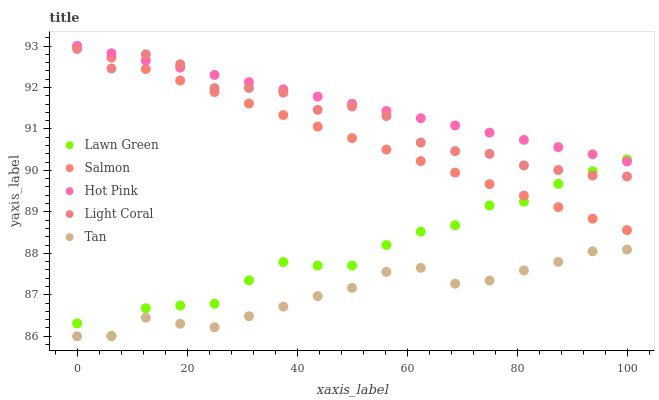Does Tan have the minimum area under the curve?
Answer yes or no. Yes. Does Hot Pink have the maximum area under the curve?
Answer yes or no. Yes. Does Lawn Green have the minimum area under the curve?
Answer yes or no. No. Does Lawn Green have the maximum area under the curve?
Answer yes or no. No. Is Hot Pink the smoothest?
Answer yes or no. Yes. Is Light Coral the roughest?
Answer yes or no. Yes. Is Lawn Green the smoothest?
Answer yes or no. No. Is Lawn Green the roughest?
Answer yes or no. No. Does Tan have the lowest value?
Answer yes or no. Yes. Does Lawn Green have the lowest value?
Answer yes or no. No. Does Salmon have the highest value?
Answer yes or no. Yes. Does Lawn Green have the highest value?
Answer yes or no. No. Is Tan less than Salmon?
Answer yes or no. Yes. Is Light Coral greater than Tan?
Answer yes or no. Yes. Does Light Coral intersect Lawn Green?
Answer yes or no. Yes. Is Light Coral less than Lawn Green?
Answer yes or no. No. Is Light Coral greater than Lawn Green?
Answer yes or no. No. Does Tan intersect Salmon?
Answer yes or no. No. 